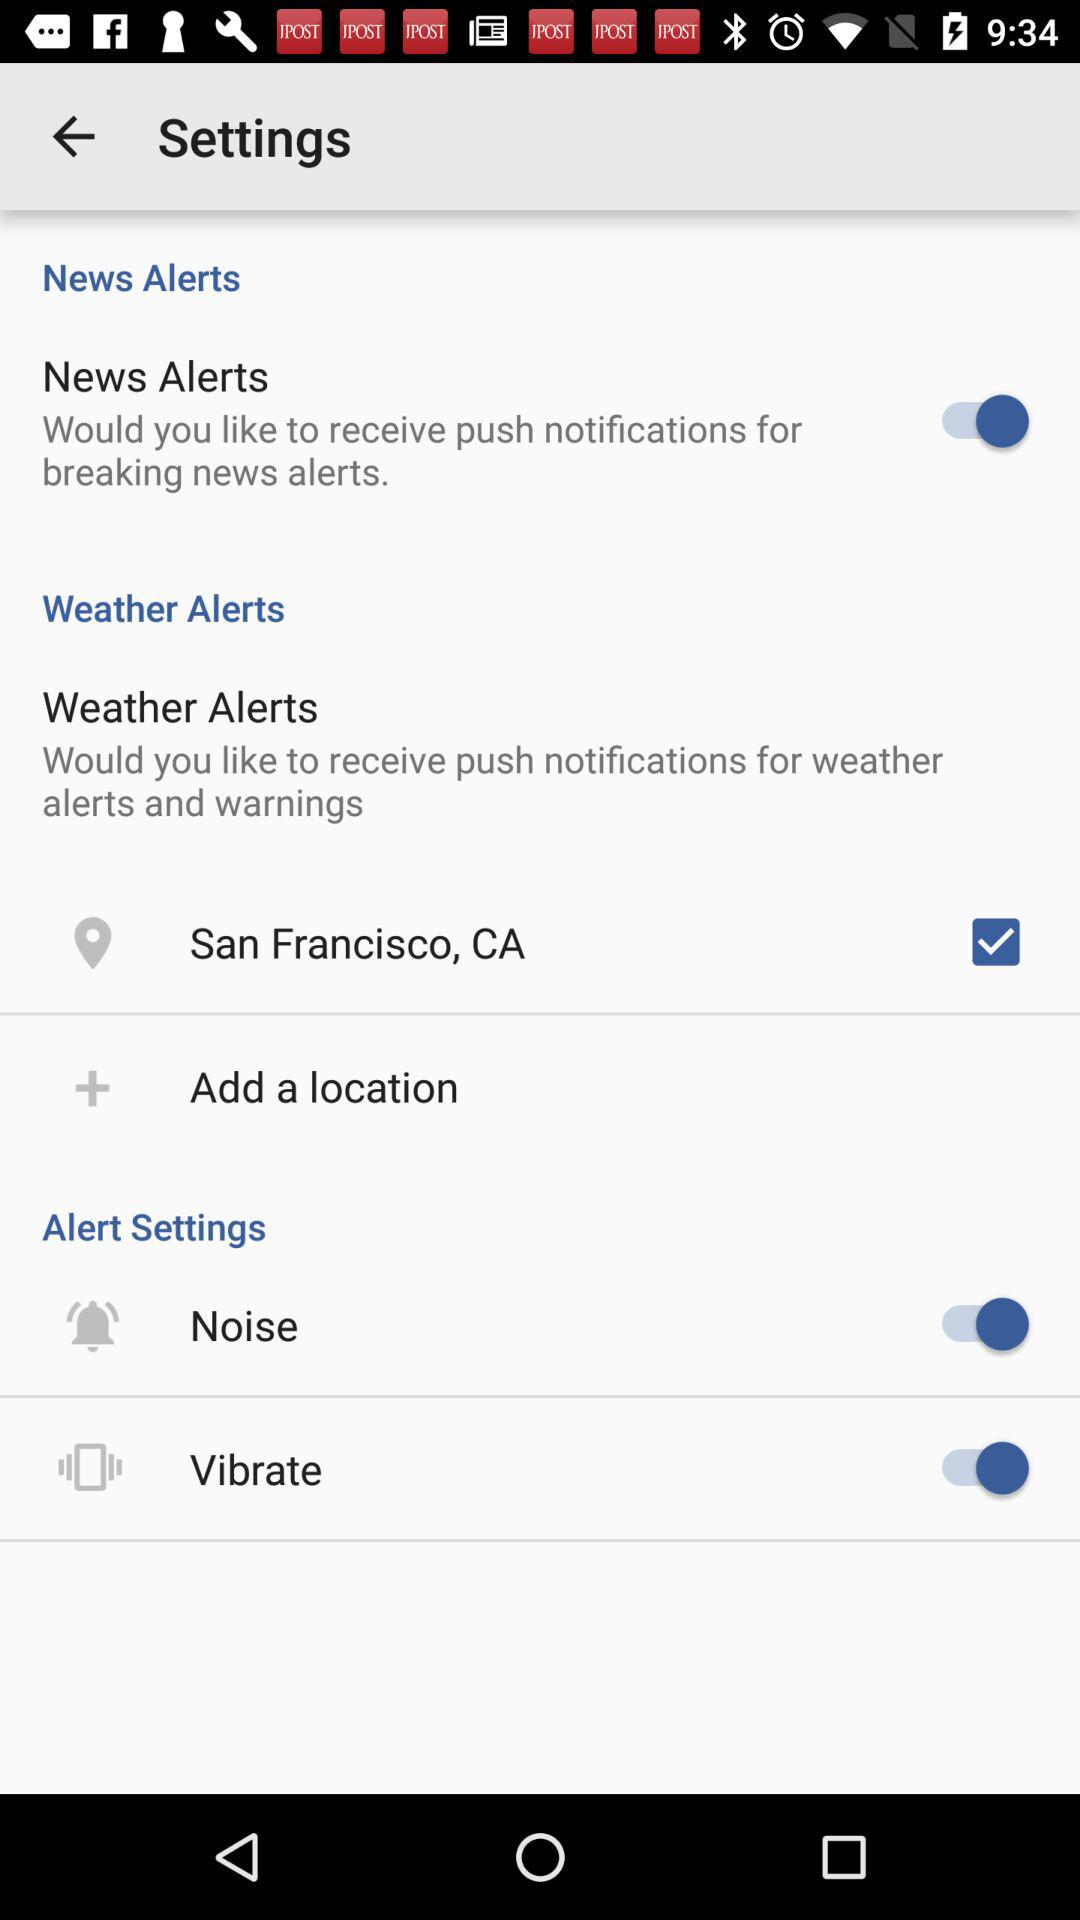What is the status of the "News Alerts"? The status of the "News Alerts" is "on". 